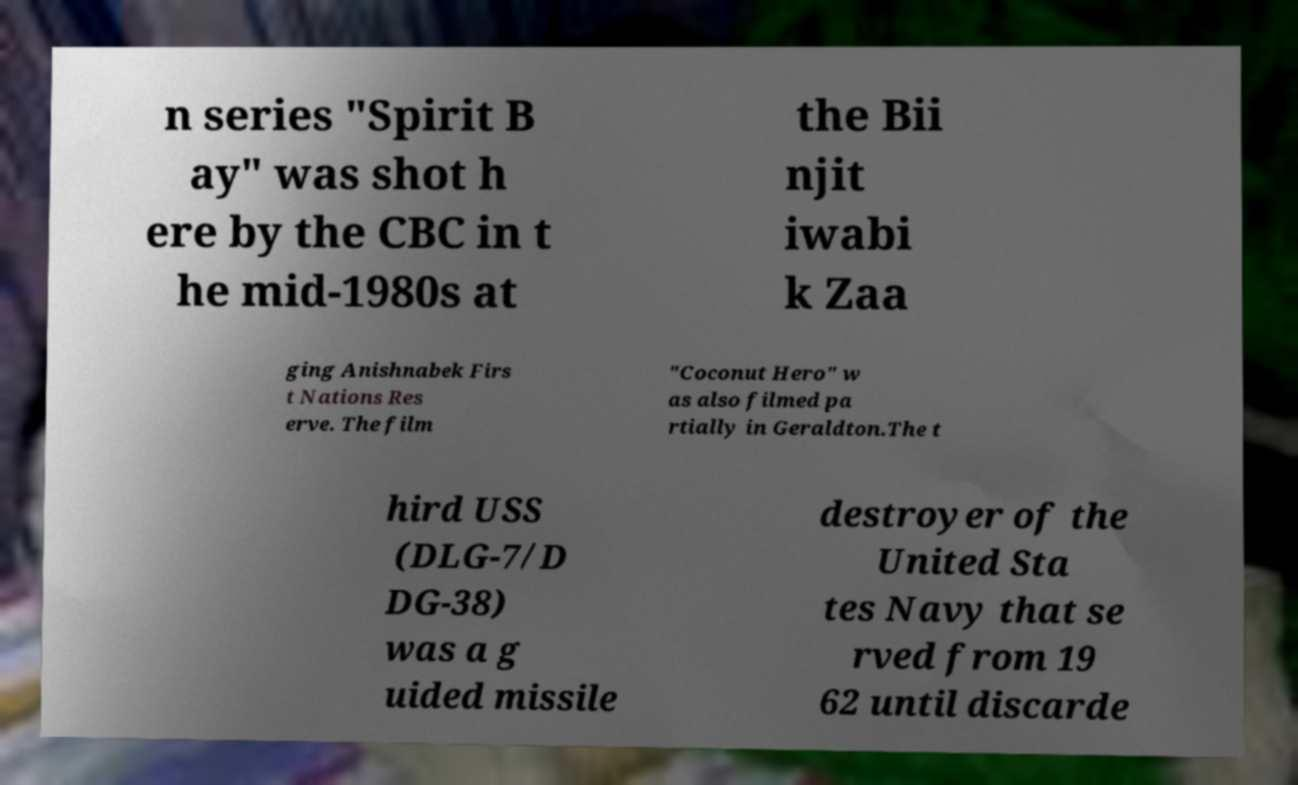Can you accurately transcribe the text from the provided image for me? n series "Spirit B ay" was shot h ere by the CBC in t he mid-1980s at the Bii njit iwabi k Zaa ging Anishnabek Firs t Nations Res erve. The film "Coconut Hero" w as also filmed pa rtially in Geraldton.The t hird USS (DLG-7/D DG-38) was a g uided missile destroyer of the United Sta tes Navy that se rved from 19 62 until discarde 